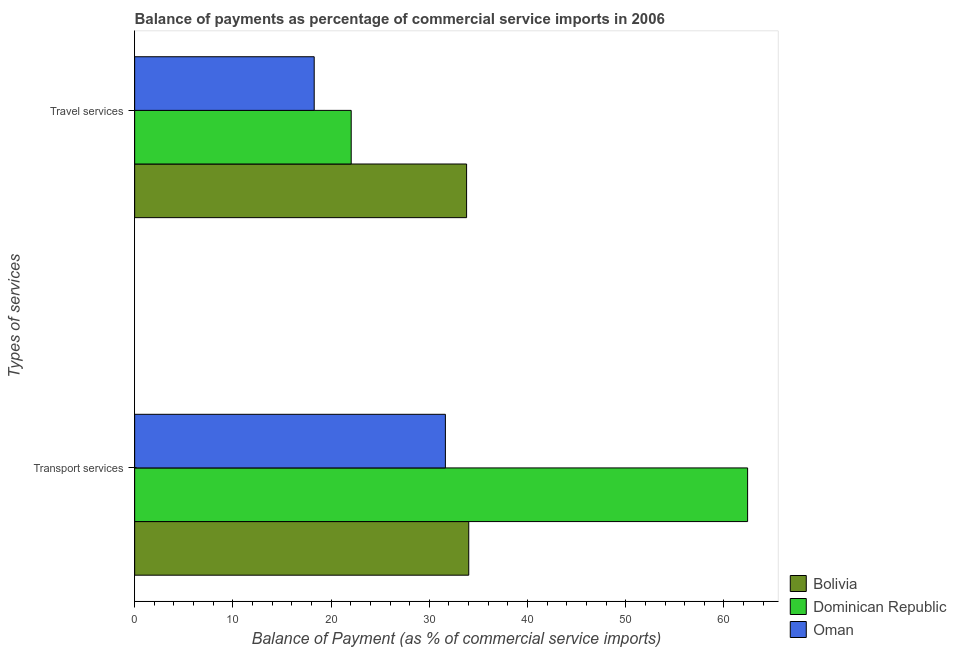How many different coloured bars are there?
Give a very brief answer. 3. Are the number of bars on each tick of the Y-axis equal?
Ensure brevity in your answer.  Yes. What is the label of the 2nd group of bars from the top?
Give a very brief answer. Transport services. What is the balance of payments of transport services in Bolivia?
Provide a succinct answer. 34.02. Across all countries, what is the maximum balance of payments of transport services?
Your response must be concise. 62.41. Across all countries, what is the minimum balance of payments of transport services?
Keep it short and to the point. 31.64. In which country was the balance of payments of transport services minimum?
Make the answer very short. Oman. What is the total balance of payments of transport services in the graph?
Provide a short and direct response. 128.07. What is the difference between the balance of payments of travel services in Bolivia and that in Oman?
Provide a succinct answer. 15.51. What is the difference between the balance of payments of transport services in Oman and the balance of payments of travel services in Bolivia?
Your answer should be compact. -2.16. What is the average balance of payments of transport services per country?
Ensure brevity in your answer.  42.69. What is the difference between the balance of payments of travel services and balance of payments of transport services in Dominican Republic?
Ensure brevity in your answer.  -40.36. What is the ratio of the balance of payments of travel services in Dominican Republic to that in Bolivia?
Your response must be concise. 0.65. Is the balance of payments of transport services in Oman less than that in Dominican Republic?
Your response must be concise. Yes. In how many countries, is the balance of payments of travel services greater than the average balance of payments of travel services taken over all countries?
Your response must be concise. 1. What does the 1st bar from the top in Travel services represents?
Make the answer very short. Oman. What does the 2nd bar from the bottom in Travel services represents?
Provide a succinct answer. Dominican Republic. How many bars are there?
Provide a succinct answer. 6. Are all the bars in the graph horizontal?
Ensure brevity in your answer.  Yes. How many countries are there in the graph?
Make the answer very short. 3. Does the graph contain any zero values?
Your answer should be very brief. No. Does the graph contain grids?
Offer a very short reply. No. How many legend labels are there?
Provide a succinct answer. 3. What is the title of the graph?
Ensure brevity in your answer.  Balance of payments as percentage of commercial service imports in 2006. What is the label or title of the X-axis?
Offer a very short reply. Balance of Payment (as % of commercial service imports). What is the label or title of the Y-axis?
Offer a terse response. Types of services. What is the Balance of Payment (as % of commercial service imports) in Bolivia in Transport services?
Make the answer very short. 34.02. What is the Balance of Payment (as % of commercial service imports) of Dominican Republic in Transport services?
Make the answer very short. 62.41. What is the Balance of Payment (as % of commercial service imports) in Oman in Transport services?
Offer a very short reply. 31.64. What is the Balance of Payment (as % of commercial service imports) in Bolivia in Travel services?
Your answer should be very brief. 33.8. What is the Balance of Payment (as % of commercial service imports) of Dominican Republic in Travel services?
Your response must be concise. 22.05. What is the Balance of Payment (as % of commercial service imports) in Oman in Travel services?
Give a very brief answer. 18.28. Across all Types of services, what is the maximum Balance of Payment (as % of commercial service imports) of Bolivia?
Offer a very short reply. 34.02. Across all Types of services, what is the maximum Balance of Payment (as % of commercial service imports) in Dominican Republic?
Give a very brief answer. 62.41. Across all Types of services, what is the maximum Balance of Payment (as % of commercial service imports) in Oman?
Provide a succinct answer. 31.64. Across all Types of services, what is the minimum Balance of Payment (as % of commercial service imports) of Bolivia?
Your answer should be very brief. 33.8. Across all Types of services, what is the minimum Balance of Payment (as % of commercial service imports) of Dominican Republic?
Your answer should be compact. 22.05. Across all Types of services, what is the minimum Balance of Payment (as % of commercial service imports) of Oman?
Your response must be concise. 18.28. What is the total Balance of Payment (as % of commercial service imports) of Bolivia in the graph?
Ensure brevity in your answer.  67.82. What is the total Balance of Payment (as % of commercial service imports) in Dominican Republic in the graph?
Offer a terse response. 84.46. What is the total Balance of Payment (as % of commercial service imports) of Oman in the graph?
Offer a terse response. 49.92. What is the difference between the Balance of Payment (as % of commercial service imports) of Bolivia in Transport services and that in Travel services?
Ensure brevity in your answer.  0.22. What is the difference between the Balance of Payment (as % of commercial service imports) of Dominican Republic in Transport services and that in Travel services?
Give a very brief answer. 40.36. What is the difference between the Balance of Payment (as % of commercial service imports) of Oman in Transport services and that in Travel services?
Keep it short and to the point. 13.36. What is the difference between the Balance of Payment (as % of commercial service imports) in Bolivia in Transport services and the Balance of Payment (as % of commercial service imports) in Dominican Republic in Travel services?
Give a very brief answer. 11.97. What is the difference between the Balance of Payment (as % of commercial service imports) in Bolivia in Transport services and the Balance of Payment (as % of commercial service imports) in Oman in Travel services?
Your answer should be very brief. 15.74. What is the difference between the Balance of Payment (as % of commercial service imports) in Dominican Republic in Transport services and the Balance of Payment (as % of commercial service imports) in Oman in Travel services?
Your answer should be very brief. 44.13. What is the average Balance of Payment (as % of commercial service imports) of Bolivia per Types of services?
Keep it short and to the point. 33.91. What is the average Balance of Payment (as % of commercial service imports) of Dominican Republic per Types of services?
Offer a very short reply. 42.23. What is the average Balance of Payment (as % of commercial service imports) of Oman per Types of services?
Give a very brief answer. 24.96. What is the difference between the Balance of Payment (as % of commercial service imports) of Bolivia and Balance of Payment (as % of commercial service imports) of Dominican Republic in Transport services?
Ensure brevity in your answer.  -28.39. What is the difference between the Balance of Payment (as % of commercial service imports) in Bolivia and Balance of Payment (as % of commercial service imports) in Oman in Transport services?
Offer a terse response. 2.38. What is the difference between the Balance of Payment (as % of commercial service imports) in Dominican Republic and Balance of Payment (as % of commercial service imports) in Oman in Transport services?
Your answer should be compact. 30.77. What is the difference between the Balance of Payment (as % of commercial service imports) of Bolivia and Balance of Payment (as % of commercial service imports) of Dominican Republic in Travel services?
Keep it short and to the point. 11.75. What is the difference between the Balance of Payment (as % of commercial service imports) in Bolivia and Balance of Payment (as % of commercial service imports) in Oman in Travel services?
Provide a short and direct response. 15.51. What is the difference between the Balance of Payment (as % of commercial service imports) of Dominican Republic and Balance of Payment (as % of commercial service imports) of Oman in Travel services?
Ensure brevity in your answer.  3.77. What is the ratio of the Balance of Payment (as % of commercial service imports) of Dominican Republic in Transport services to that in Travel services?
Offer a very short reply. 2.83. What is the ratio of the Balance of Payment (as % of commercial service imports) of Oman in Transport services to that in Travel services?
Make the answer very short. 1.73. What is the difference between the highest and the second highest Balance of Payment (as % of commercial service imports) in Bolivia?
Provide a short and direct response. 0.22. What is the difference between the highest and the second highest Balance of Payment (as % of commercial service imports) in Dominican Republic?
Offer a very short reply. 40.36. What is the difference between the highest and the second highest Balance of Payment (as % of commercial service imports) of Oman?
Your response must be concise. 13.36. What is the difference between the highest and the lowest Balance of Payment (as % of commercial service imports) of Bolivia?
Your response must be concise. 0.22. What is the difference between the highest and the lowest Balance of Payment (as % of commercial service imports) of Dominican Republic?
Provide a succinct answer. 40.36. What is the difference between the highest and the lowest Balance of Payment (as % of commercial service imports) in Oman?
Offer a very short reply. 13.36. 